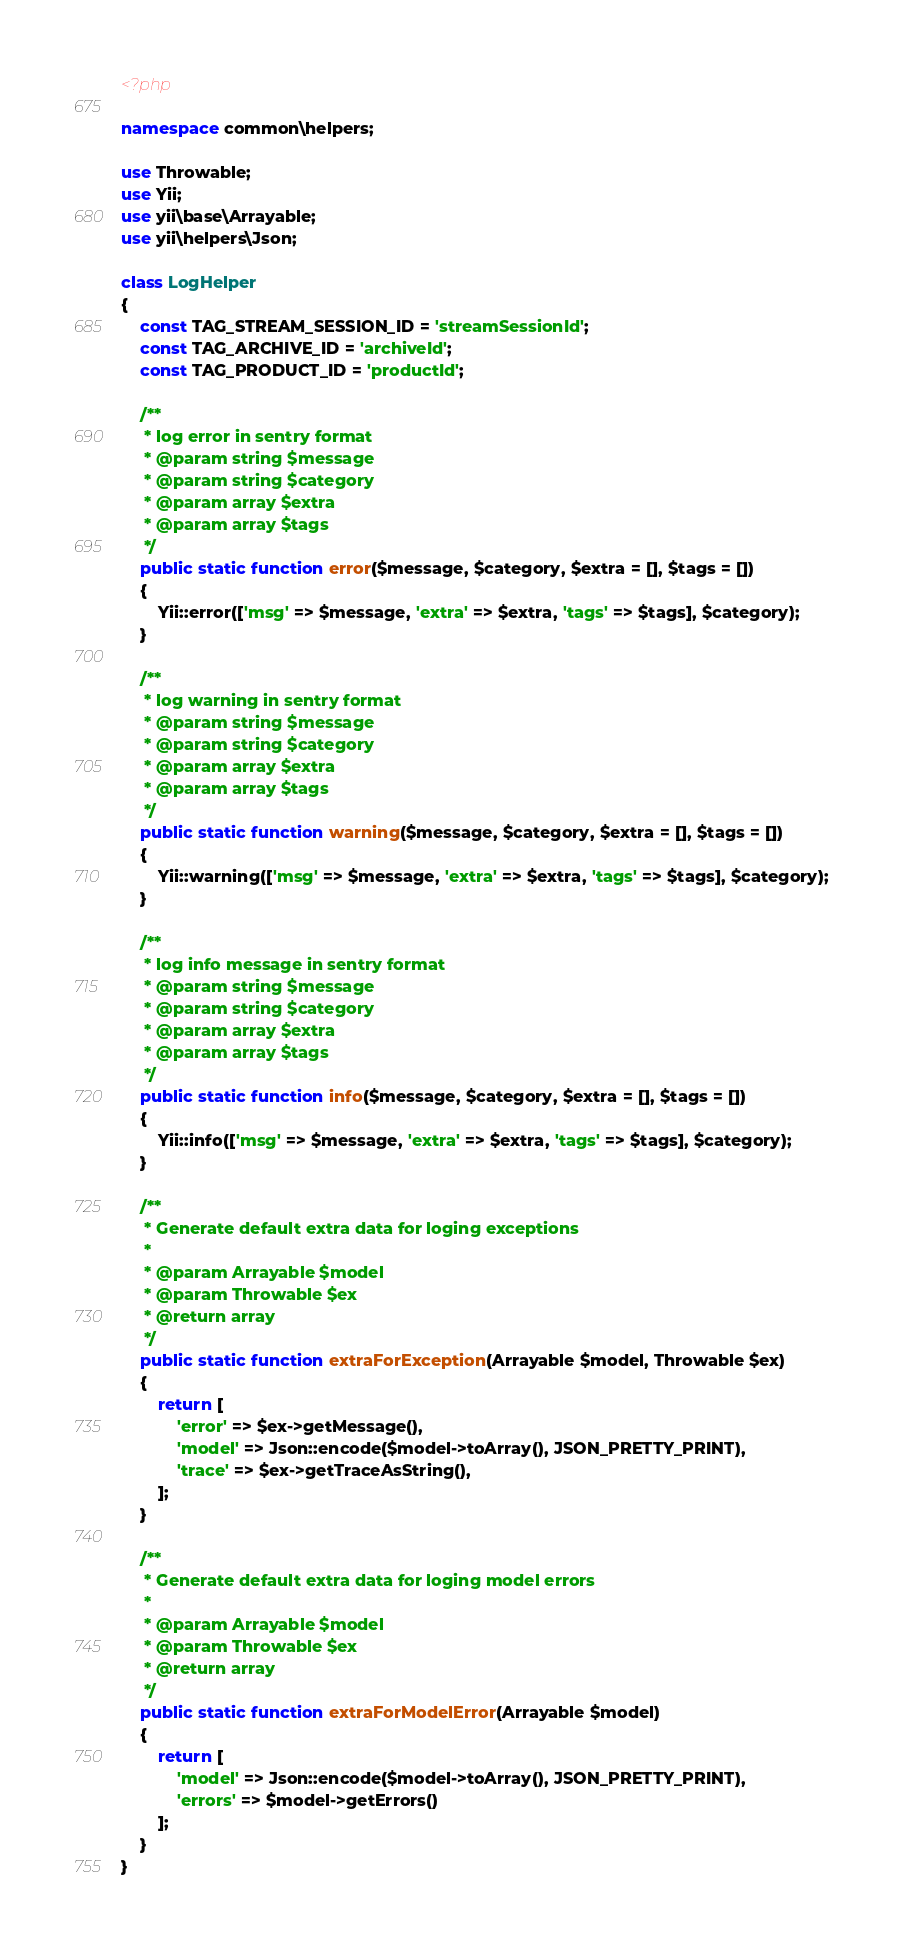<code> <loc_0><loc_0><loc_500><loc_500><_PHP_><?php

namespace common\helpers;

use Throwable;
use Yii;
use yii\base\Arrayable;
use yii\helpers\Json;

class LogHelper
{
    const TAG_STREAM_SESSION_ID = 'streamSessionId';
    const TAG_ARCHIVE_ID = 'archiveId';
    const TAG_PRODUCT_ID = 'productId';

    /**
     * log error in sentry format
     * @param string $message
     * @param string $category
     * @param array $extra
     * @param array $tags
     */
    public static function error($message, $category, $extra = [], $tags = [])
    {
        Yii::error(['msg' => $message, 'extra' => $extra, 'tags' => $tags], $category);
    }

    /**
     * log warning in sentry format
     * @param string $message
     * @param string $category
     * @param array $extra
     * @param array $tags
     */
    public static function warning($message, $category, $extra = [], $tags = [])
    {
        Yii::warning(['msg' => $message, 'extra' => $extra, 'tags' => $tags], $category);
    }

    /**
     * log info message in sentry format
     * @param string $message
     * @param string $category
     * @param array $extra
     * @param array $tags
     */
    public static function info($message, $category, $extra = [], $tags = [])
    {
        Yii::info(['msg' => $message, 'extra' => $extra, 'tags' => $tags], $category);
    }

    /**
     * Generate default extra data for loging exceptions
     *
     * @param Arrayable $model
     * @param Throwable $ex
     * @return array
     */
    public static function extraForException(Arrayable $model, Throwable $ex)
    {
        return [
            'error' => $ex->getMessage(),
            'model' => Json::encode($model->toArray(), JSON_PRETTY_PRINT),
            'trace' => $ex->getTraceAsString(),
        ];
    }

    /**
     * Generate default extra data for loging model errors
     *
     * @param Arrayable $model
     * @param Throwable $ex
     * @return array
     */
    public static function extraForModelError(Arrayable $model)
    {
        return [
            'model' => Json::encode($model->toArray(), JSON_PRETTY_PRINT),
            'errors' => $model->getErrors()
        ];
    }
}
</code> 